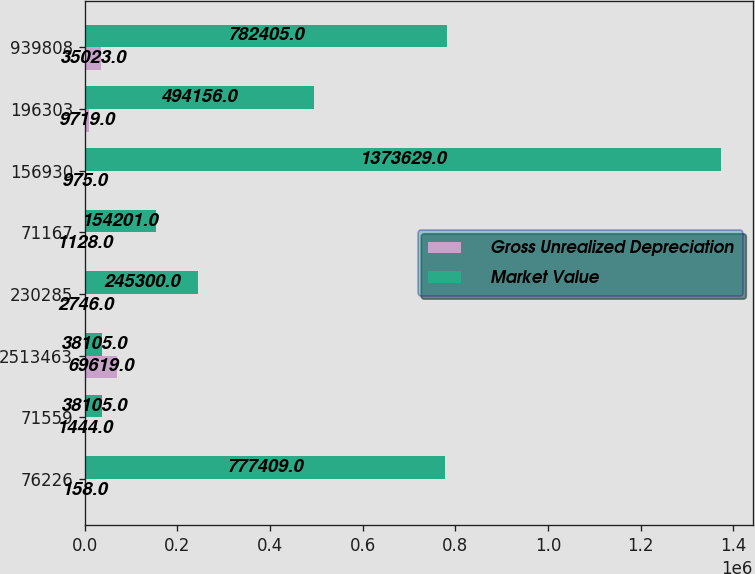Convert chart to OTSL. <chart><loc_0><loc_0><loc_500><loc_500><stacked_bar_chart><ecel><fcel>76226<fcel>71559<fcel>2513463<fcel>230285<fcel>71167<fcel>156930<fcel>196303<fcel>939808<nl><fcel>Gross Unrealized Depreciation<fcel>158<fcel>1444<fcel>69619<fcel>2746<fcel>1128<fcel>975<fcel>9719<fcel>35023<nl><fcel>Market Value<fcel>777409<fcel>38105<fcel>38105<fcel>245300<fcel>154201<fcel>1.37363e+06<fcel>494156<fcel>782405<nl></chart> 